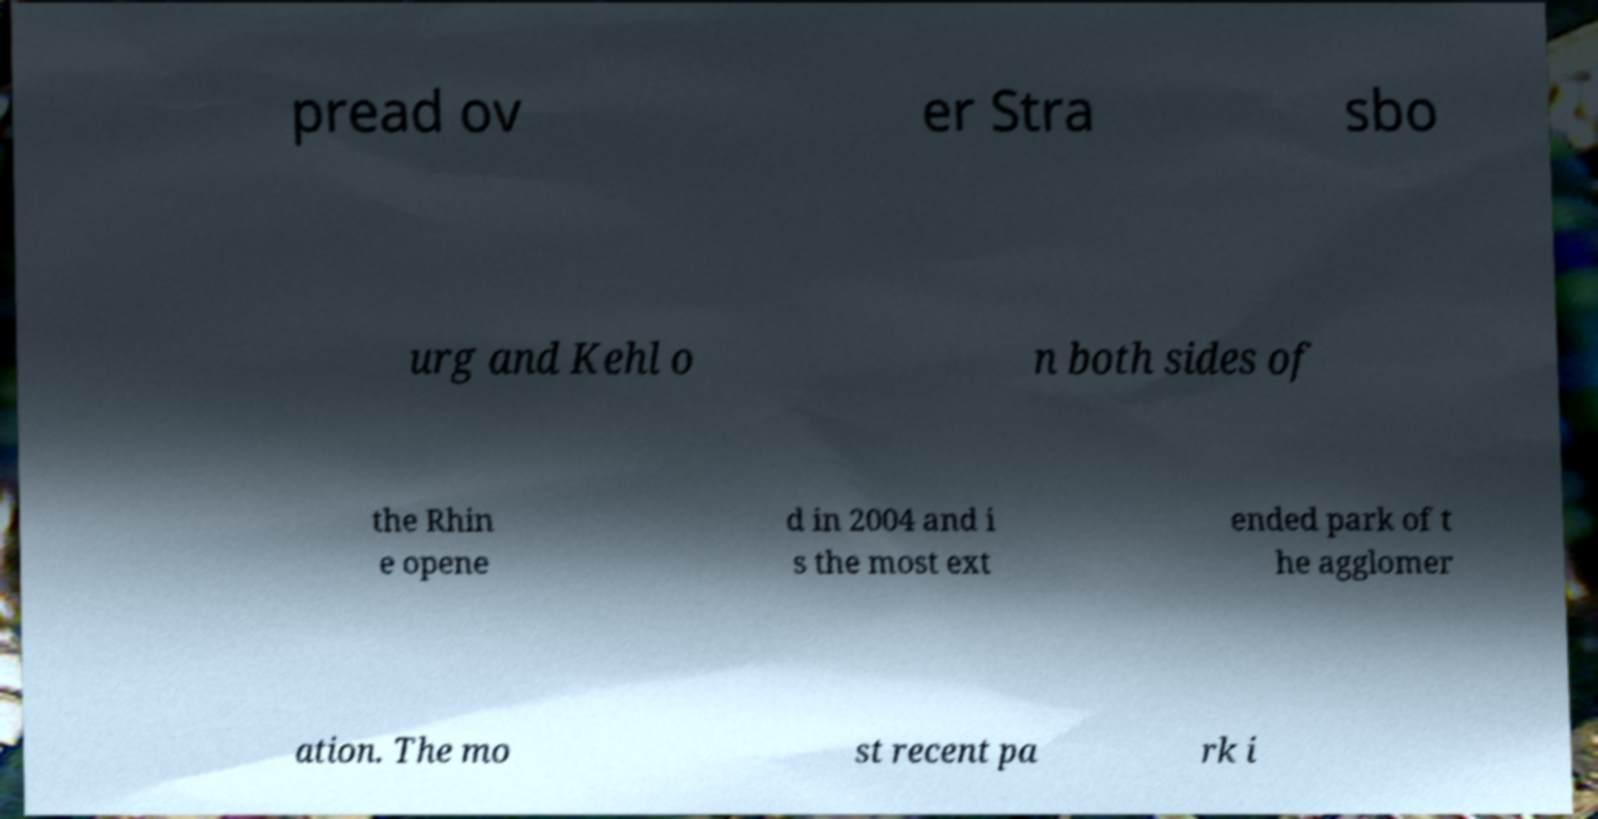I need the written content from this picture converted into text. Can you do that? pread ov er Stra sbo urg and Kehl o n both sides of the Rhin e opene d in 2004 and i s the most ext ended park of t he agglomer ation. The mo st recent pa rk i 